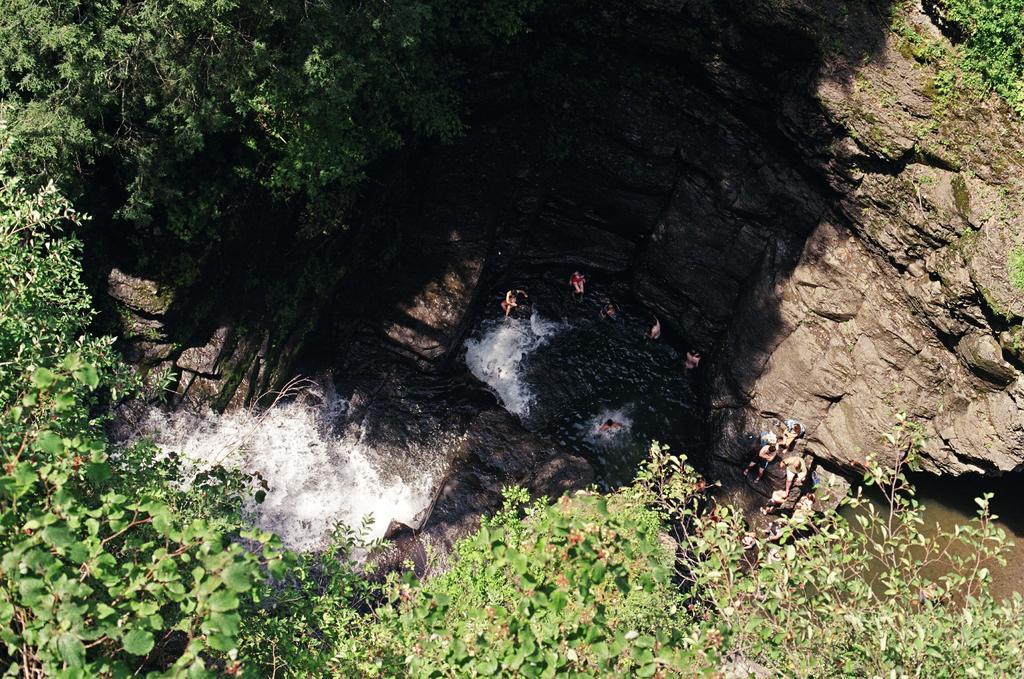Please provide a concise description of this image. In this picture we can see waterfalls, some people are in the water, around we can see full of trees and rocks. 